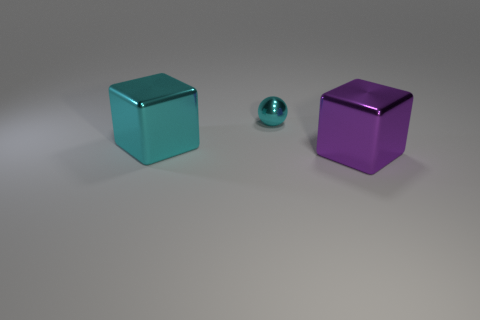Is there anything else that has the same shape as the tiny shiny object?
Your answer should be very brief. No. The cyan object that is in front of the small sphere has what shape?
Your response must be concise. Cube. Does the purple metallic object have the same shape as the big cyan object?
Offer a very short reply. Yes. Is the number of large metallic blocks behind the purple shiny thing the same as the number of small things?
Your answer should be compact. Yes. The small metal thing is what shape?
Your response must be concise. Sphere. Is there any other thing of the same color as the tiny metal object?
Provide a short and direct response. Yes. Do the metal block behind the purple object and the block that is on the right side of the tiny shiny sphere have the same size?
Make the answer very short. Yes. What is the shape of the big object that is right of the large metallic thing behind the purple cube?
Ensure brevity in your answer.  Cube. Do the purple thing and the object that is to the left of the cyan metal sphere have the same size?
Keep it short and to the point. Yes. How big is the metallic ball that is to the left of the thing that is in front of the block that is on the left side of the tiny object?
Give a very brief answer. Small. 